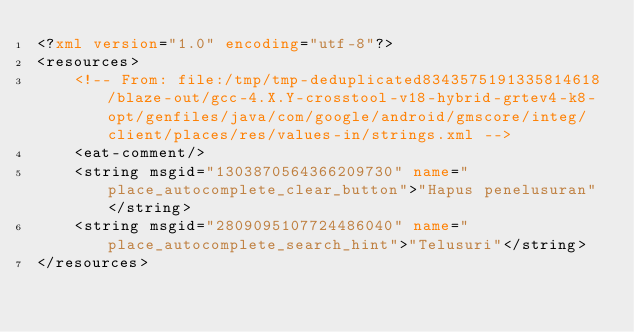<code> <loc_0><loc_0><loc_500><loc_500><_XML_><?xml version="1.0" encoding="utf-8"?>
<resources>
    <!-- From: file:/tmp/tmp-deduplicated8343575191335814618/blaze-out/gcc-4.X.Y-crosstool-v18-hybrid-grtev4-k8-opt/genfiles/java/com/google/android/gmscore/integ/client/places/res/values-in/strings.xml -->
    <eat-comment/>
    <string msgid="1303870564366209730" name="place_autocomplete_clear_button">"Hapus penelusuran"</string>
    <string msgid="2809095107724486040" name="place_autocomplete_search_hint">"Telusuri"</string>
</resources></code> 